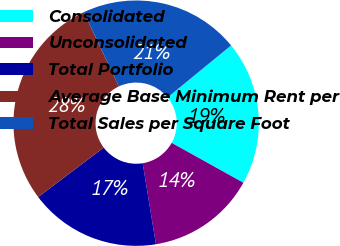Convert chart to OTSL. <chart><loc_0><loc_0><loc_500><loc_500><pie_chart><fcel>Consolidated<fcel>Unconsolidated<fcel>Total Portfolio<fcel>Average Base Minimum Rent per<fcel>Total Sales per Square Foot<nl><fcel>18.99%<fcel>14.35%<fcel>17.3%<fcel>28.27%<fcel>21.1%<nl></chart> 